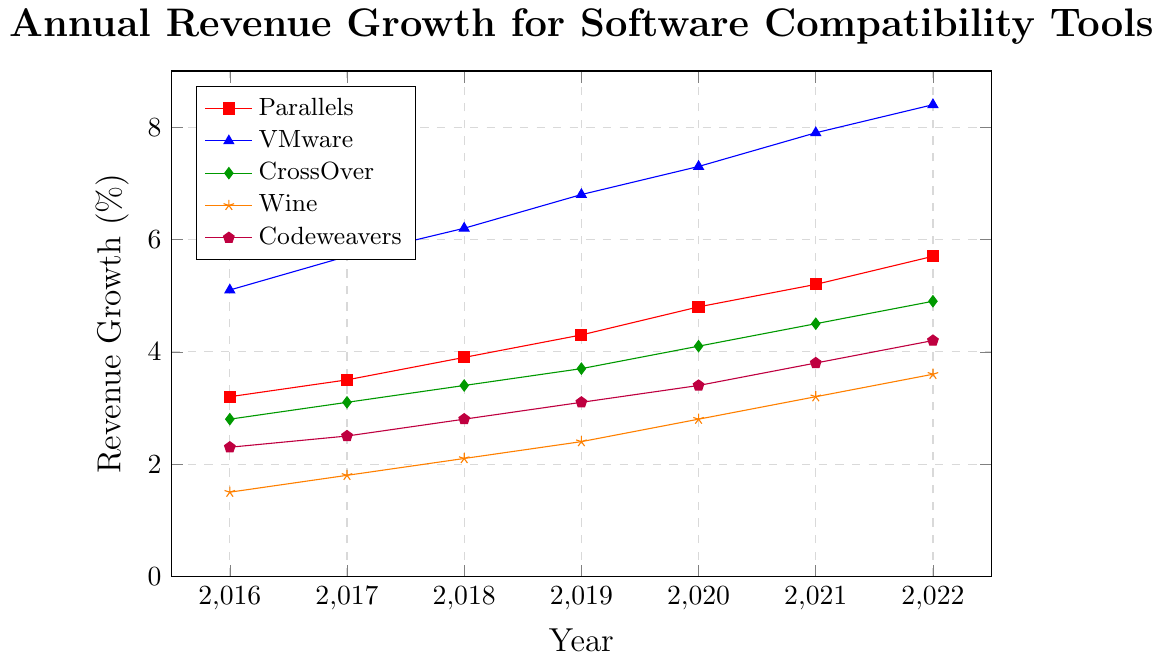what color represents the Codeweavers line? The legend indicates the corresponding color and marker for each tool. According to the legend, Codeweavers are represented using a purple line with a pentagon marker.
Answer: purple Between 2019 and 2020, which provider saw the largest absolute growth in revenue? Calculate the difference between the revenue values for 2020 and 2019 for each provider. VMware has the largest difference: \(7.3 - 6.8 = 0.5\).
Answer: VMware What is the annual growth rate for Parallels from 2016 to 2022? Calculate the difference in revenue for Parallels between 2016 and 2022, and divide by the number of years (2022 - 2016 = 6). The growth is \(5.7 - 3.2 = 2.5\), so the annual growth rate is \( \frac{2.5}{6} \approx 0.42 \% \).
Answer: 0.42% What is the combined revenue growth for CrossOver and Codeweavers in 2021? Look for the revenue values for CrossOver and Codeweavers in 2021 and add them together. \(4.5 + 3.8 = 8.3 \% \).
Answer: 8.3% Which tool provider showed the least growth percentage from 2016 to 2022? Calculate the total growth for each provider by subtracting the 2016 value from the 2022 value. Wine shows the least growth: \(3.6 - 1.5 = 2.1\).
Answer: Wine How does VMware's growth in 2022 compare to 2021? Compare the revenue growth values for VMware between 2022 and 2021. The growth is \(8.4 - 7.9 = 0.5 \% \).
Answer: 0.5% Which year shows the highest revenue for Parallels? Look for the highest value in Parallels' revenue growth across all years. The highest value is 5.7% in 2022.
Answer: 2022 Which company experienced the highest revenue growth overall between 2016 and 2022? Calculate the total growth for each provider by subtracting the 2016 value from the 2022 value. VMware has the highest growth: \(8.4 - 5.1 = 3.3\).
Answer: VMware Identify the tool provider that showed a constant increase in revenue every year. Examine each provider's revenue growth per year to identify the trend. Codeweavers consistently increased yearly.
Answer: Codeweavers What is the average revenue growth for Wine from 2016 to 2022? Sum the revenue growth values for Wine from 2016 to 2022 and divide by the number of years (7). The total is \(1.5 + 1.8 + 2.1 + 2.4 + 2.8 + 3.2 + 3.6 = 17.4\), so the average is \( \frac{17.4}{7} \approx 2.49\) .
Answer: 2.49% 